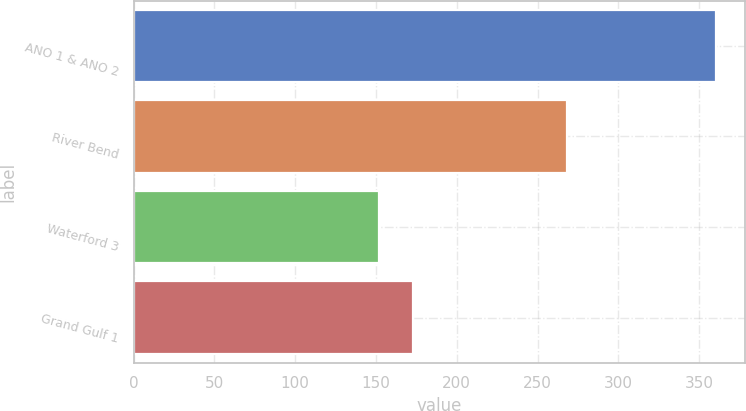<chart> <loc_0><loc_0><loc_500><loc_500><bar_chart><fcel>ANO 1 & ANO 2<fcel>River Bend<fcel>Waterford 3<fcel>Grand Gulf 1<nl><fcel>360.5<fcel>267.9<fcel>152<fcel>172.9<nl></chart> 